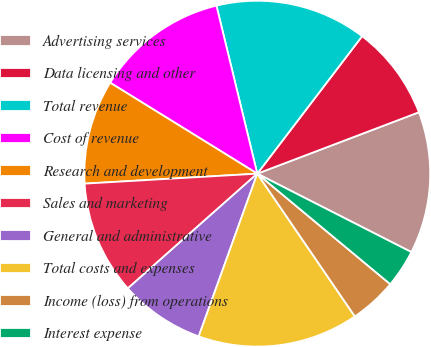<chart> <loc_0><loc_0><loc_500><loc_500><pie_chart><fcel>Advertising services<fcel>Data licensing and other<fcel>Total revenue<fcel>Cost of revenue<fcel>Research and development<fcel>Sales and marketing<fcel>General and administrative<fcel>Total costs and expenses<fcel>Income (loss) from operations<fcel>Interest expense<nl><fcel>13.27%<fcel>8.85%<fcel>14.16%<fcel>12.39%<fcel>9.73%<fcel>10.62%<fcel>7.96%<fcel>15.04%<fcel>4.42%<fcel>3.54%<nl></chart> 